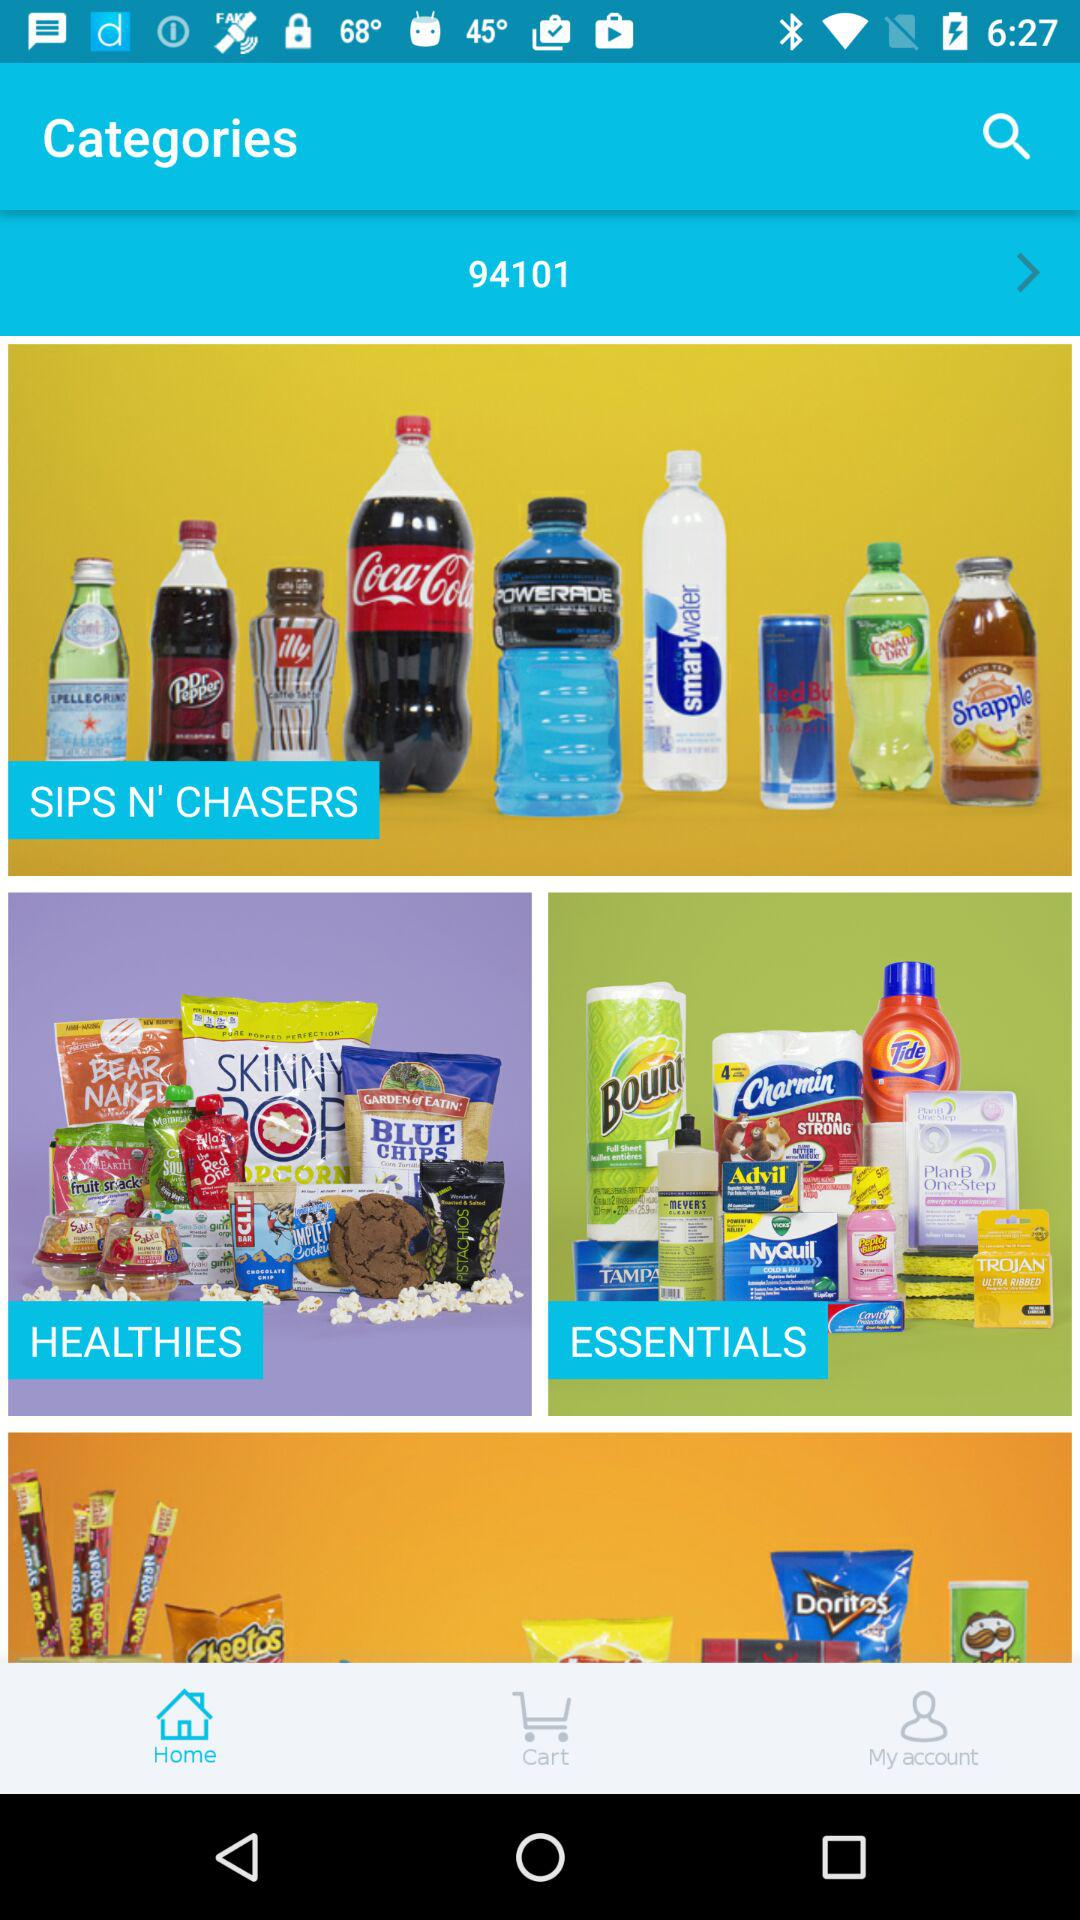Which tab is selected? The selected tab is home. 